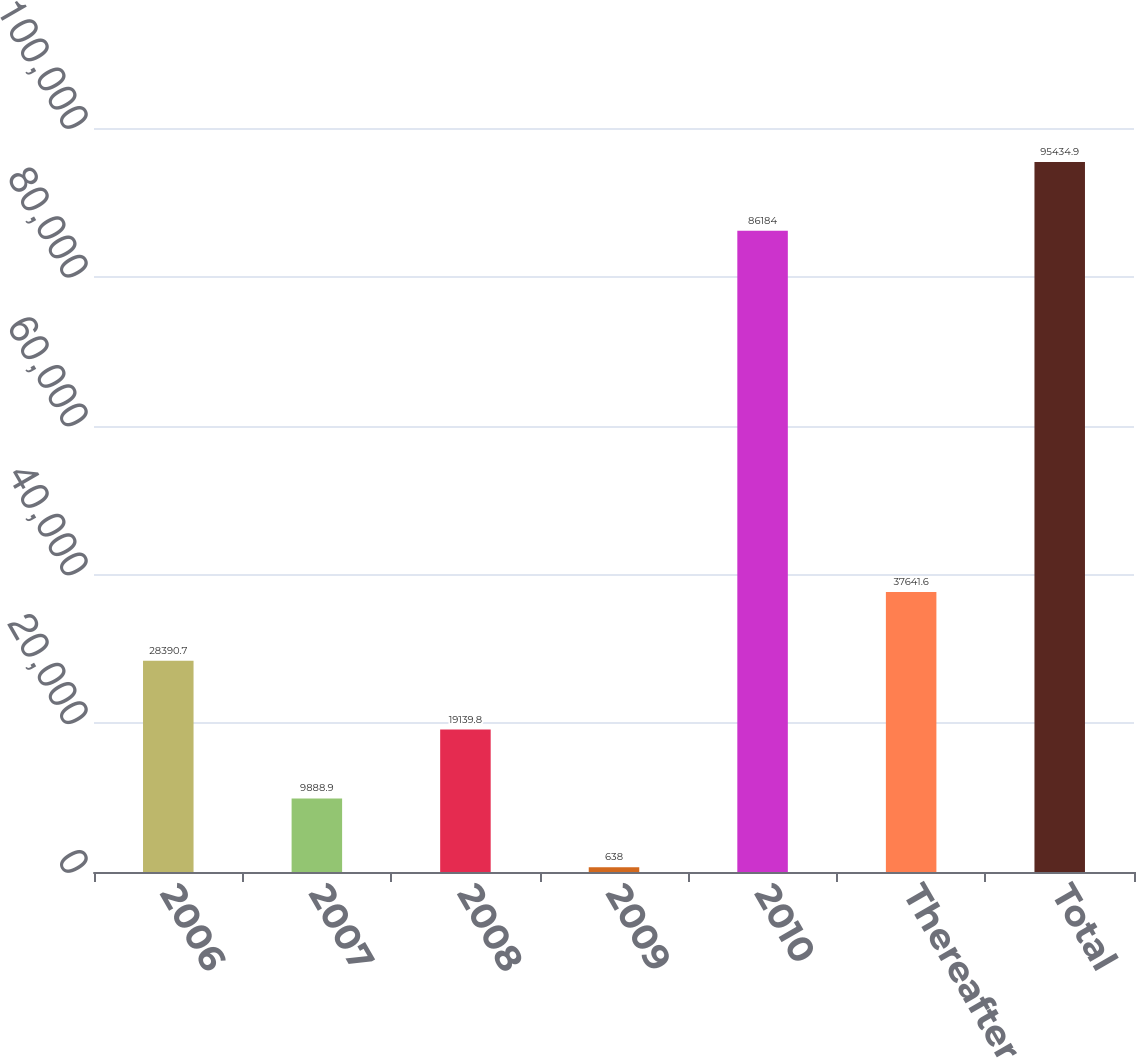Convert chart to OTSL. <chart><loc_0><loc_0><loc_500><loc_500><bar_chart><fcel>2006<fcel>2007<fcel>2008<fcel>2009<fcel>2010<fcel>Thereafter<fcel>Total<nl><fcel>28390.7<fcel>9888.9<fcel>19139.8<fcel>638<fcel>86184<fcel>37641.6<fcel>95434.9<nl></chart> 